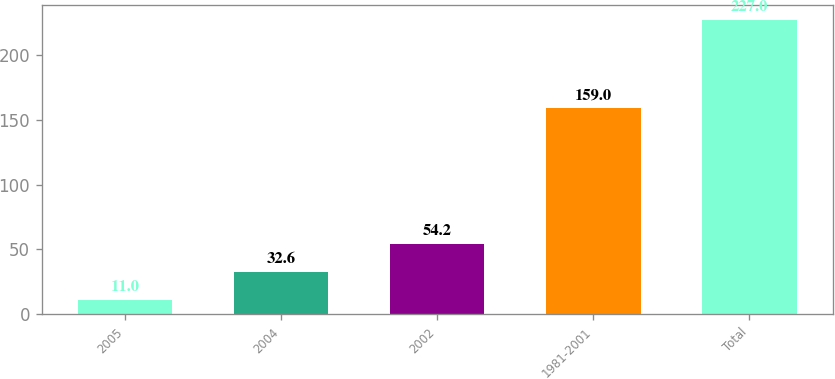<chart> <loc_0><loc_0><loc_500><loc_500><bar_chart><fcel>2005<fcel>2004<fcel>2002<fcel>1981-2001<fcel>Total<nl><fcel>11<fcel>32.6<fcel>54.2<fcel>159<fcel>227<nl></chart> 